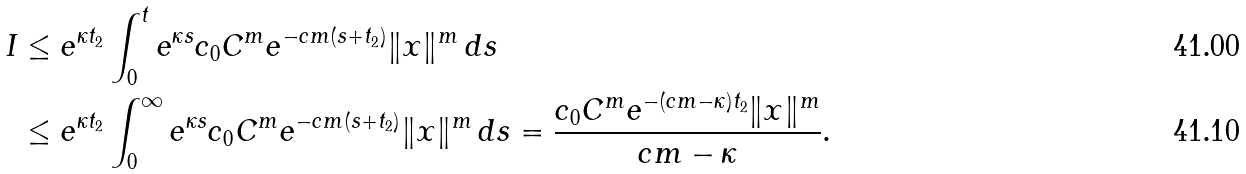<formula> <loc_0><loc_0><loc_500><loc_500>I & \leq e ^ { \kappa t _ { 2 } } \int _ { 0 } ^ { t } e ^ { \kappa s } c _ { 0 } C ^ { m } e ^ { - c m ( s + t _ { 2 } ) } \| x \| ^ { m } \, d s \\ & \leq e ^ { \kappa t _ { 2 } } \int _ { 0 } ^ { \infty } e ^ { \kappa s } c _ { 0 } C ^ { m } e ^ { - c m ( s + t _ { 2 } ) } \| x \| ^ { m } \, d s = \frac { c _ { 0 } C ^ { m } e ^ { - ( c m - \kappa ) t _ { 2 } } \| x \| ^ { m } } { c m - \kappa } .</formula> 